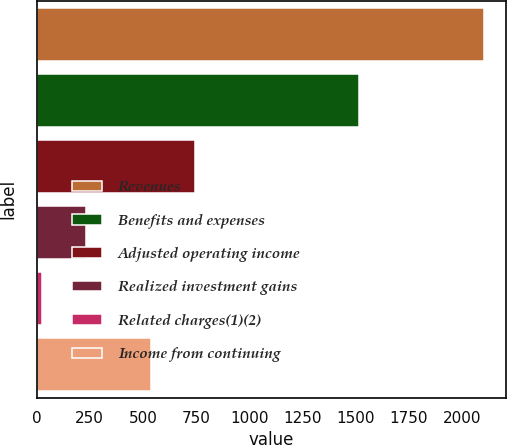<chart> <loc_0><loc_0><loc_500><loc_500><bar_chart><fcel>Revenues<fcel>Benefits and expenses<fcel>Adjusted operating income<fcel>Realized investment gains<fcel>Related charges(1)(2)<fcel>Income from continuing<nl><fcel>2101<fcel>1515<fcel>746.6<fcel>232.6<fcel>25<fcel>539<nl></chart> 